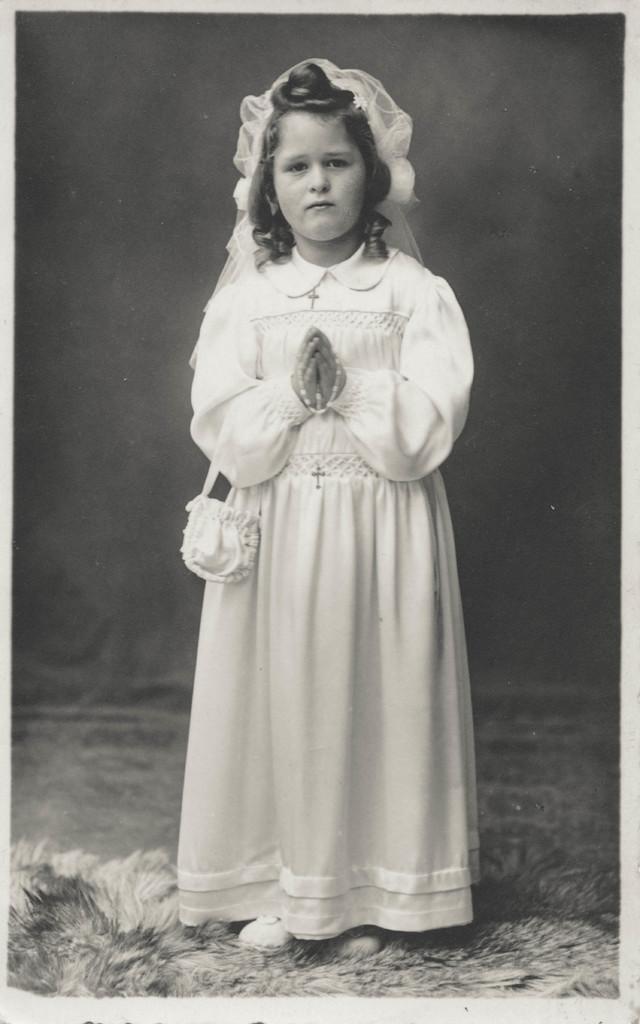Could you give a brief overview of what you see in this image? In this picture I can observe a girl in the middle of the picture. This is a black and white image. 